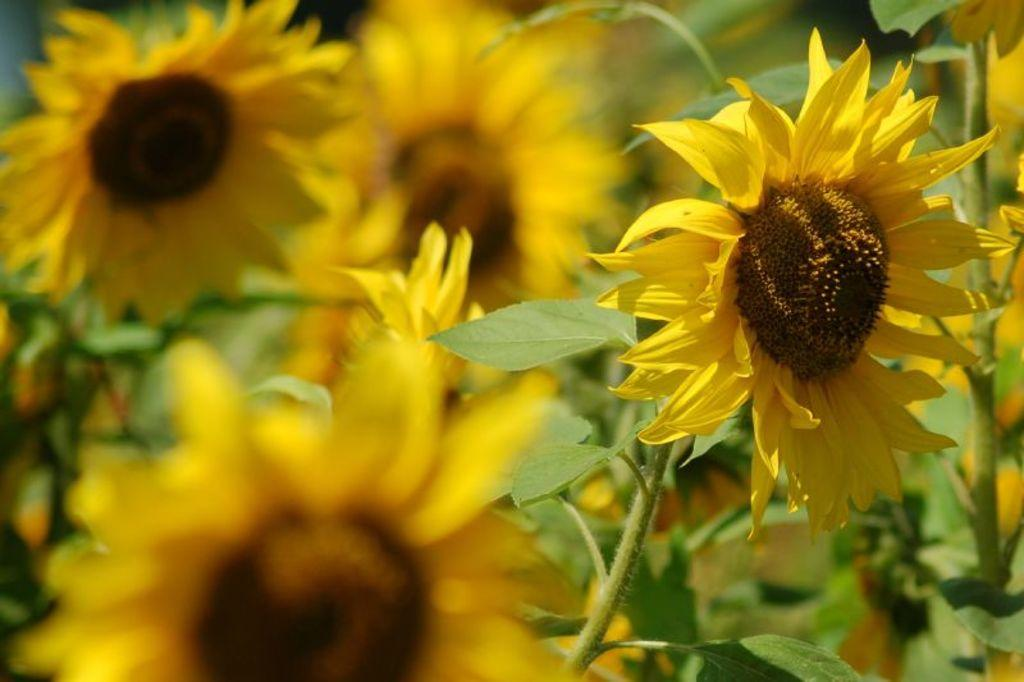What type of flowers are in the image? There are sunflowers in the image. Where are the sunflowers located? The sunflowers are on plants. What type of sack is being used to hold the sunflowers in the image? There is no sack present in the image; the sunflowers are on plants. What color is the yarn used to tie the sunflowers together in the image? There is no yarn or tying of sunflowers in the image; they are on plants. 